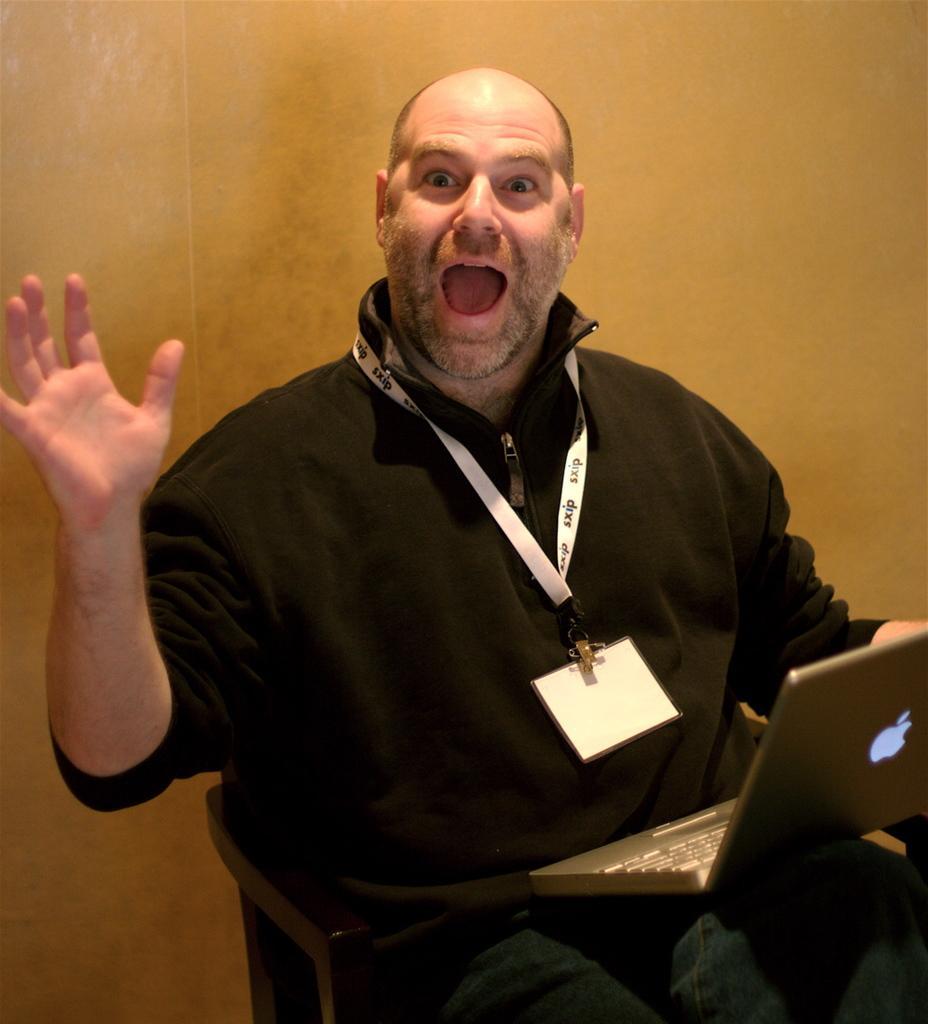Describe this image in one or two sentences. In this image in the center there is one person who is sitting on chair, and he is screaming and he is holding a laptop and in the background there is wall. 